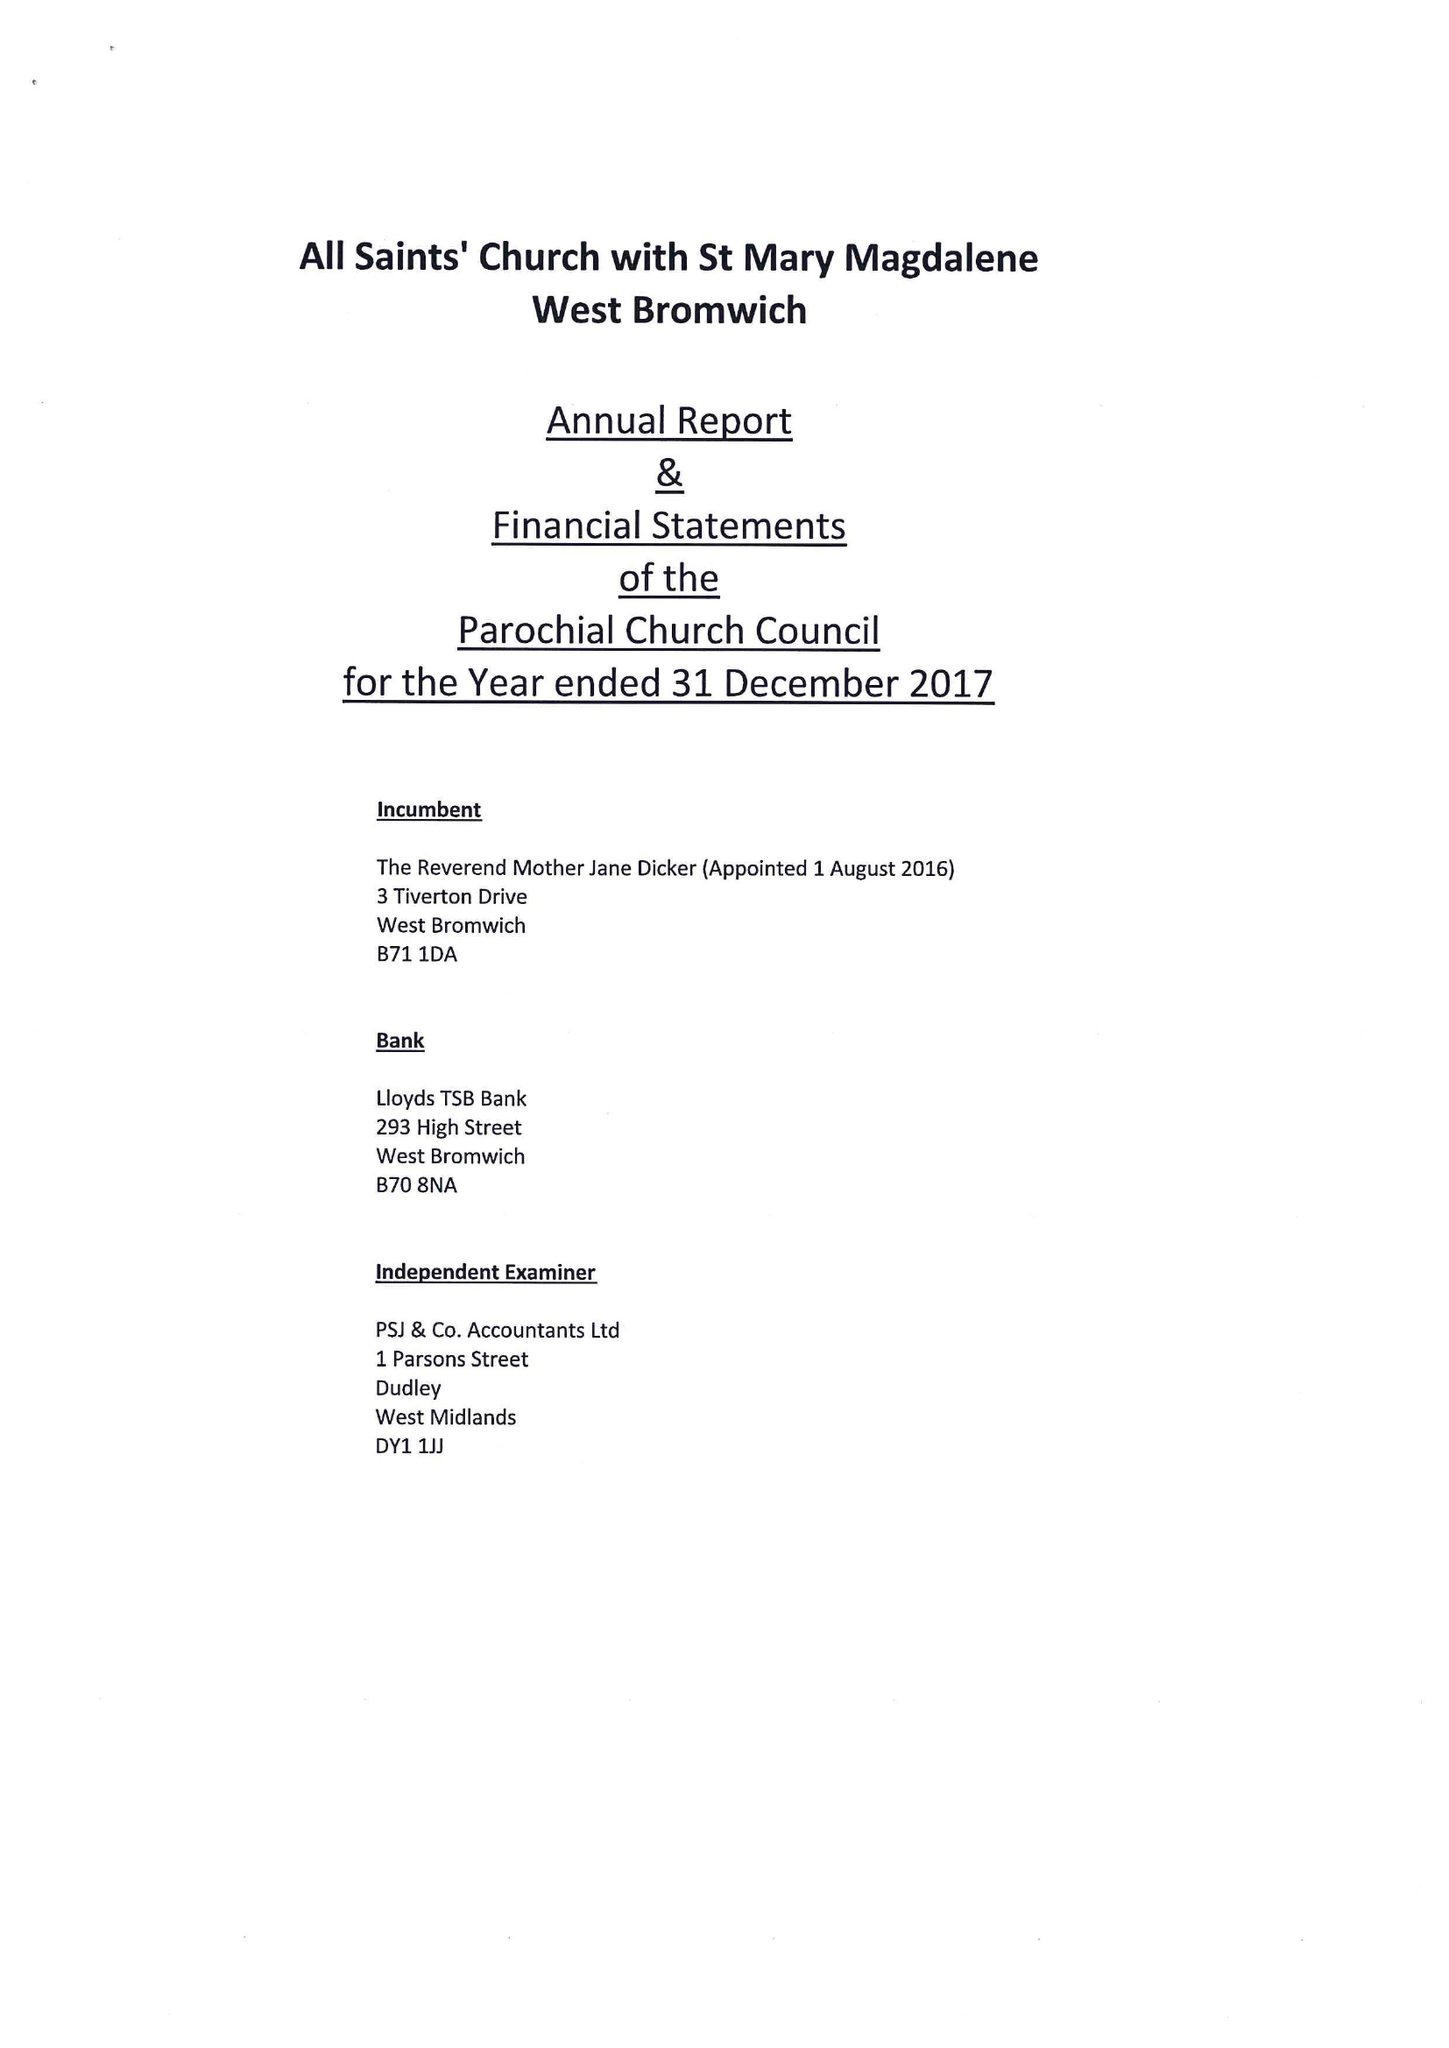What is the value for the spending_annually_in_british_pounds?
Answer the question using a single word or phrase. 143788.04 